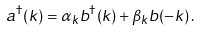<formula> <loc_0><loc_0><loc_500><loc_500>a ^ { \dag } ( { k } ) = \alpha _ { k } b ^ { \dag } ( { k } ) + \beta _ { k } b ( - { k } ) \, .</formula> 